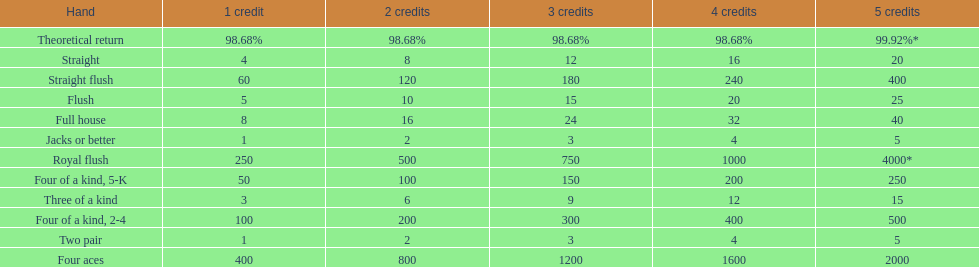At most, what could a person earn for having a full house? 40. 